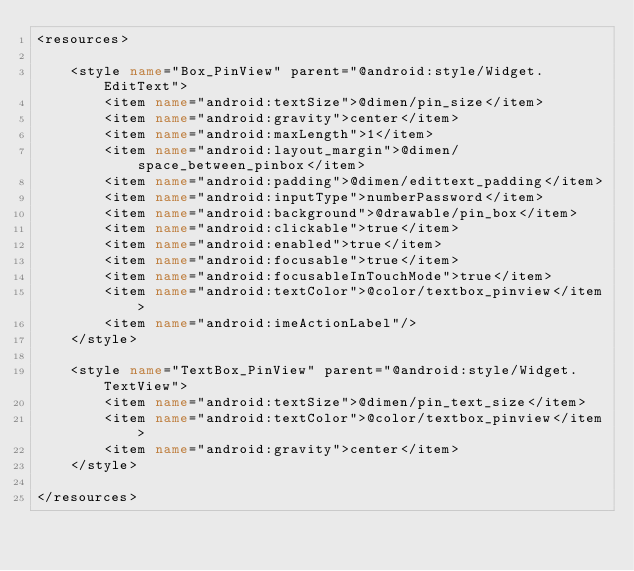Convert code to text. <code><loc_0><loc_0><loc_500><loc_500><_XML_><resources>

    <style name="Box_PinView" parent="@android:style/Widget.EditText">
        <item name="android:textSize">@dimen/pin_size</item>
        <item name="android:gravity">center</item>
        <item name="android:maxLength">1</item>
        <item name="android:layout_margin">@dimen/space_between_pinbox</item>
        <item name="android:padding">@dimen/edittext_padding</item>
        <item name="android:inputType">numberPassword</item>
        <item name="android:background">@drawable/pin_box</item>
        <item name="android:clickable">true</item>
        <item name="android:enabled">true</item>
        <item name="android:focusable">true</item>
        <item name="android:focusableInTouchMode">true</item>
        <item name="android:textColor">@color/textbox_pinview</item>
        <item name="android:imeActionLabel"/>
    </style>

    <style name="TextBox_PinView" parent="@android:style/Widget.TextView">
        <item name="android:textSize">@dimen/pin_text_size</item>
        <item name="android:textColor">@color/textbox_pinview</item>
        <item name="android:gravity">center</item>
    </style>

</resources></code> 